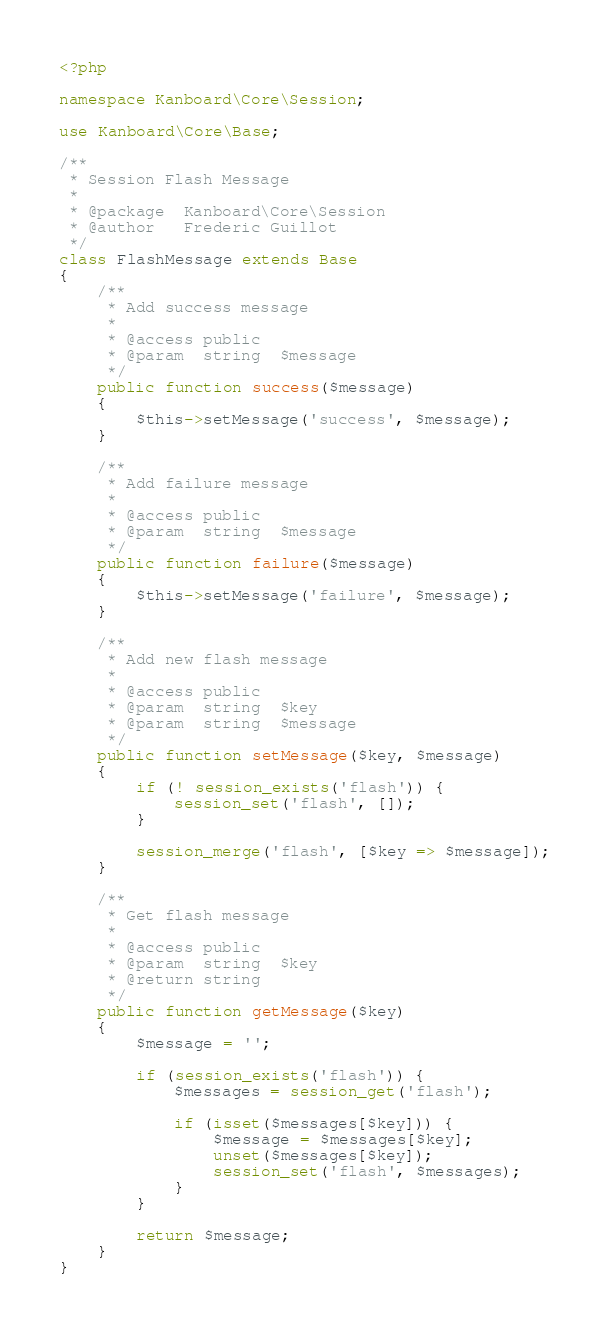Convert code to text. <code><loc_0><loc_0><loc_500><loc_500><_PHP_><?php

namespace Kanboard\Core\Session;

use Kanboard\Core\Base;

/**
 * Session Flash Message
 *
 * @package  Kanboard\Core\Session
 * @author   Frederic Guillot
 */
class FlashMessage extends Base
{
    /**
     * Add success message
     *
     * @access public
     * @param  string  $message
     */
    public function success($message)
    {
        $this->setMessage('success', $message);
    }

    /**
     * Add failure message
     *
     * @access public
     * @param  string  $message
     */
    public function failure($message)
    {
        $this->setMessage('failure', $message);
    }

    /**
     * Add new flash message
     *
     * @access public
     * @param  string  $key
     * @param  string  $message
     */
    public function setMessage($key, $message)
    {
        if (! session_exists('flash')) {
            session_set('flash', []);
        }

        session_merge('flash', [$key => $message]);
    }

    /**
     * Get flash message
     *
     * @access public
     * @param  string  $key
     * @return string
     */
    public function getMessage($key)
    {
        $message = '';

        if (session_exists('flash')) {
            $messages = session_get('flash');

            if (isset($messages[$key])) {
                $message = $messages[$key];
                unset($messages[$key]);
                session_set('flash', $messages);
            }
        }

        return $message;
    }
}
</code> 